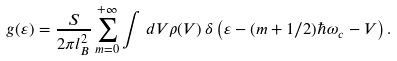Convert formula to latex. <formula><loc_0><loc_0><loc_500><loc_500>g ( \varepsilon ) = \frac { S } { 2 \pi l _ { B } ^ { 2 } } \sum _ { m = 0 } ^ { + \infty } \int \, d V \rho ( V ) \, \delta \left ( \varepsilon - ( m + 1 / 2 ) \hbar { \omega } _ { c } - V \right ) .</formula> 